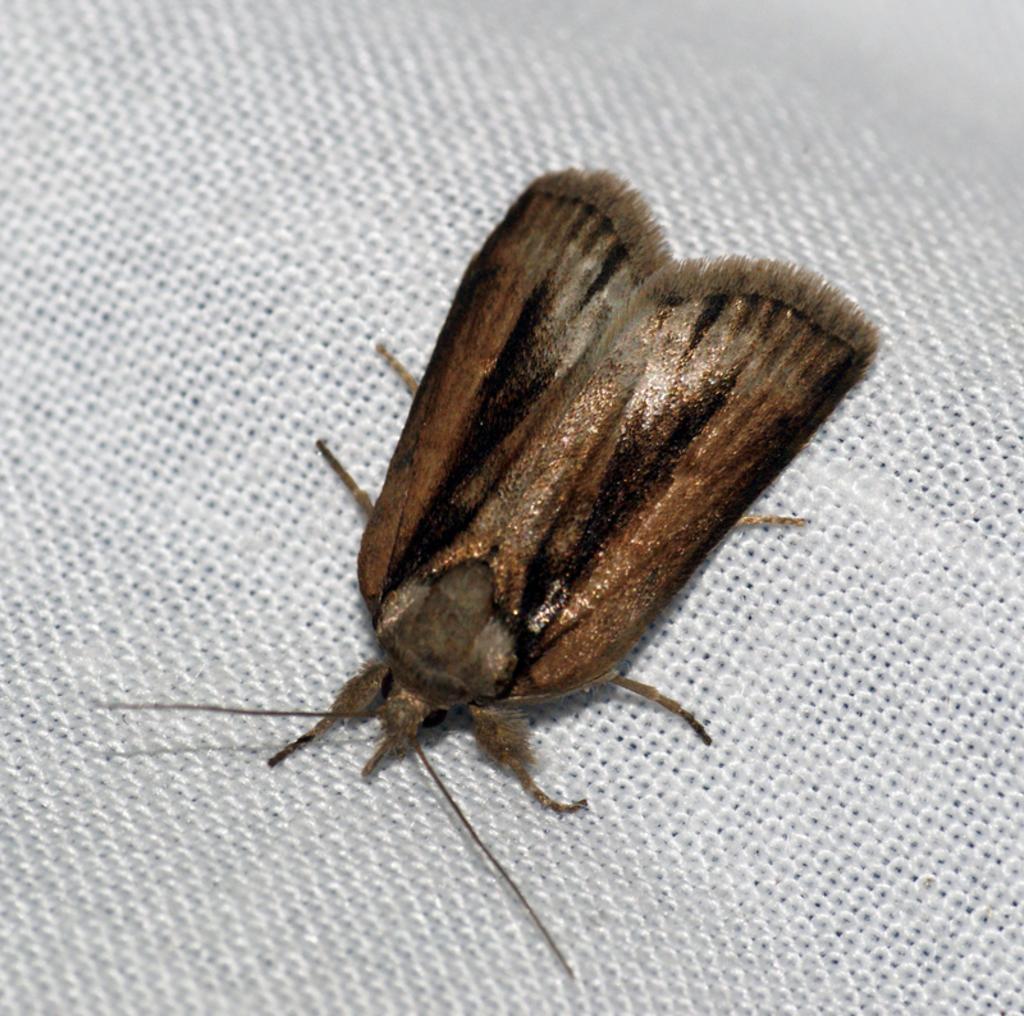Please provide a concise description of this image. In this picture there is an insect in the center of the image. 